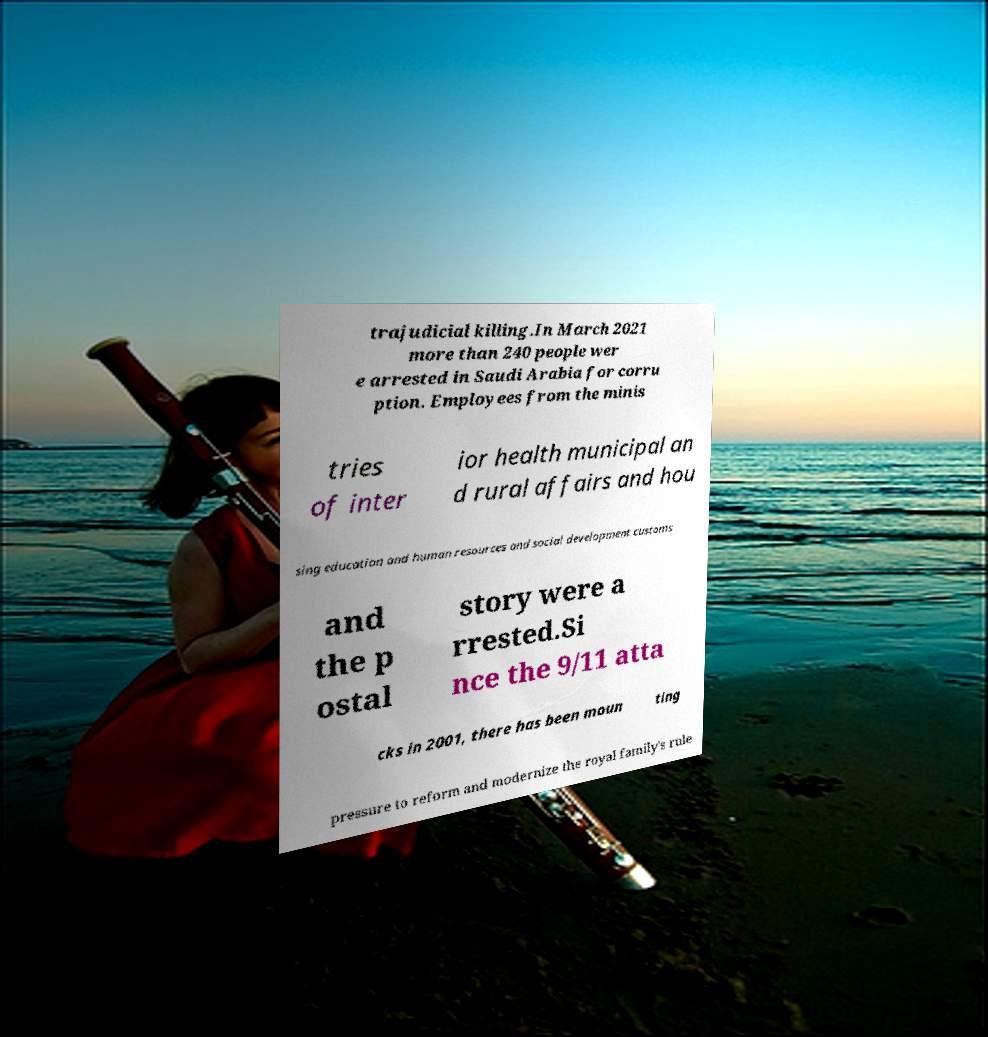Can you accurately transcribe the text from the provided image for me? trajudicial killing.In March 2021 more than 240 people wer e arrested in Saudi Arabia for corru ption. Employees from the minis tries of inter ior health municipal an d rural affairs and hou sing education and human resources and social development customs and the p ostal story were a rrested.Si nce the 9/11 atta cks in 2001, there has been moun ting pressure to reform and modernize the royal family's rule 